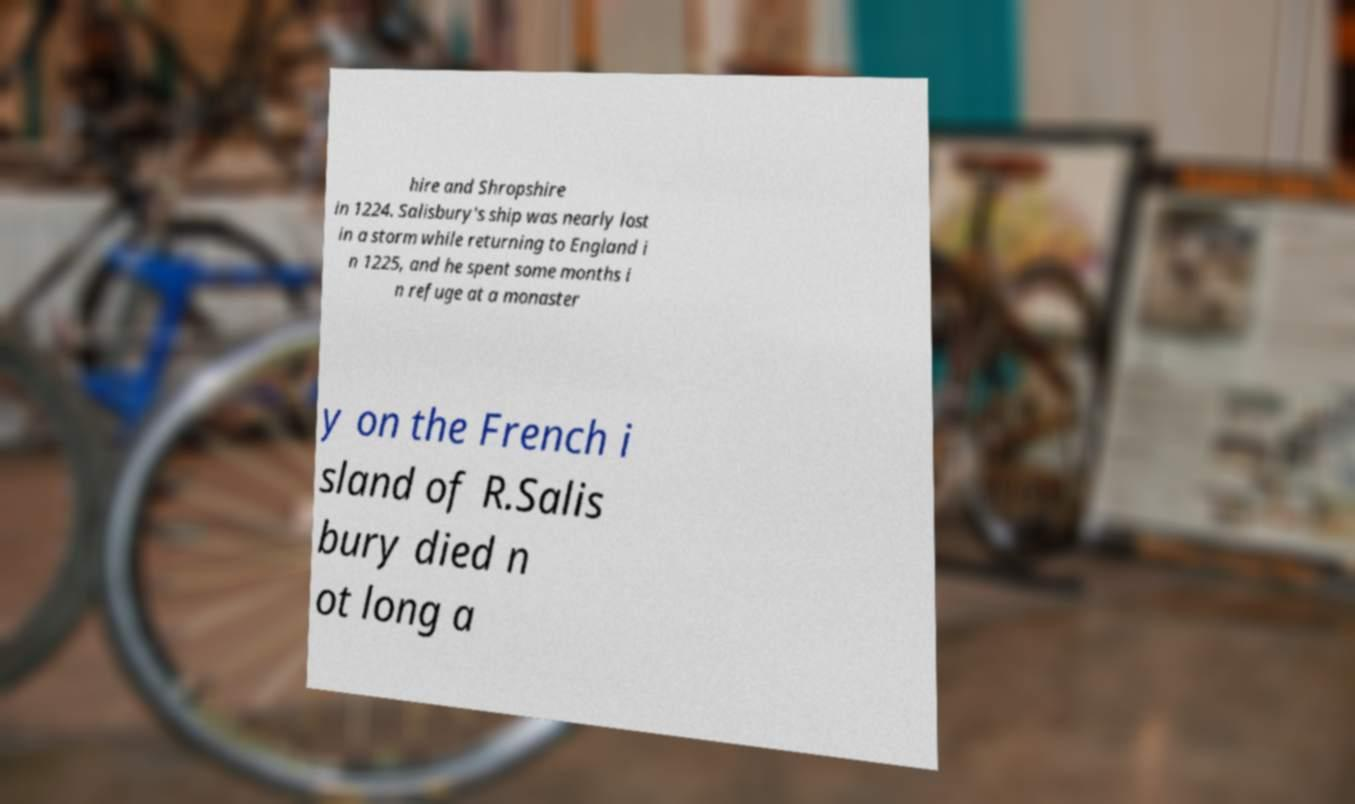What messages or text are displayed in this image? I need them in a readable, typed format. hire and Shropshire in 1224. Salisbury's ship was nearly lost in a storm while returning to England i n 1225, and he spent some months i n refuge at a monaster y on the French i sland of R.Salis bury died n ot long a 